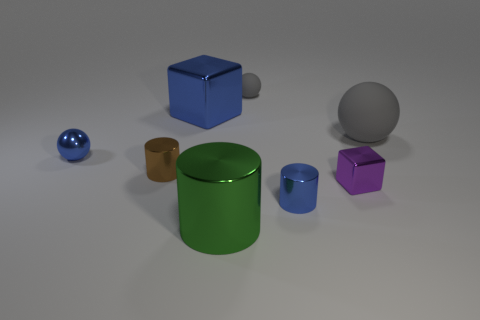Are any cyan things visible?
Make the answer very short. No. Is the small brown metallic thing the same shape as the big green object?
Give a very brief answer. Yes. What number of big objects are either gray matte things or green metal cylinders?
Provide a short and direct response. 2. What color is the big cube?
Your answer should be compact. Blue. What is the shape of the big object in front of the small metallic cylinder that is to the left of the green cylinder?
Provide a succinct answer. Cylinder. Is there a blue cube that has the same material as the green thing?
Offer a terse response. Yes. There is a blue metal object that is in front of the shiny sphere; is it the same size as the large blue thing?
Ensure brevity in your answer.  No. How many gray objects are either large rubber things or big metallic blocks?
Your response must be concise. 1. There is a tiny cylinder behind the small cube; what material is it?
Your answer should be compact. Metal. There is a metal cylinder that is behind the purple thing; how many big shiny objects are behind it?
Provide a short and direct response. 1. 